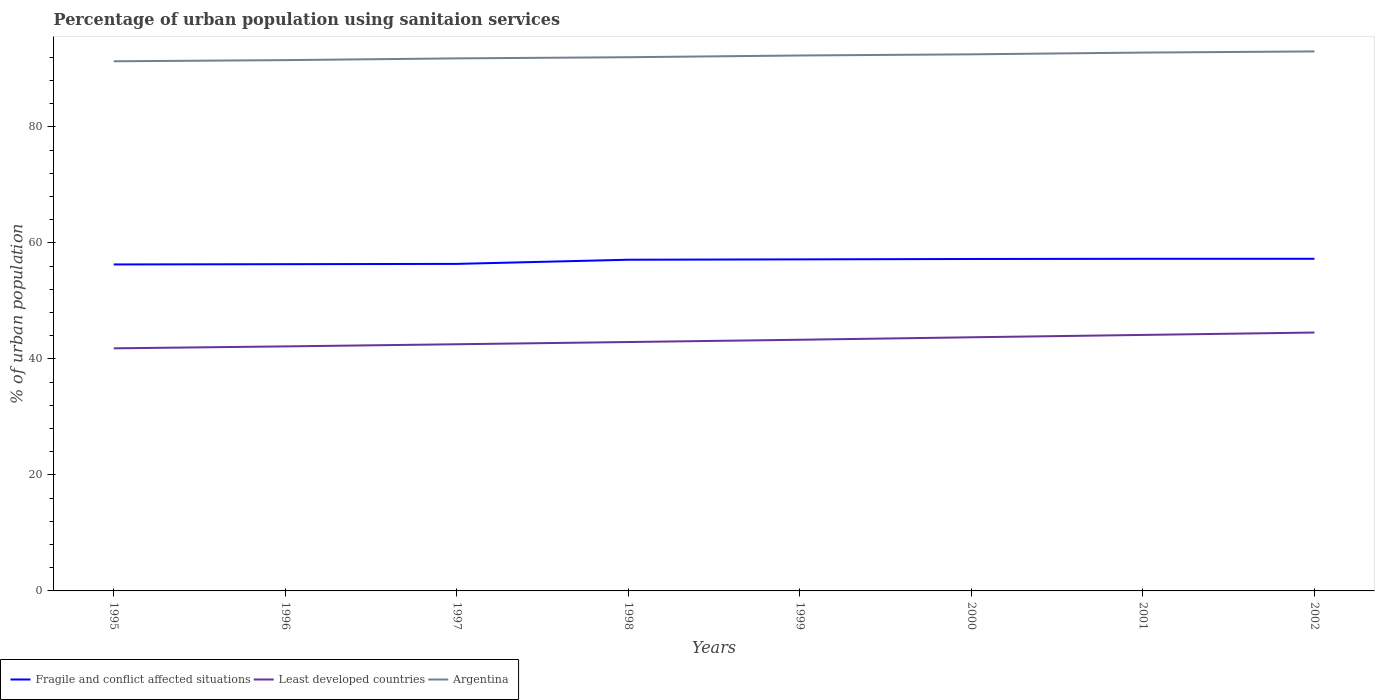Does the line corresponding to Fragile and conflict affected situations intersect with the line corresponding to Least developed countries?
Ensure brevity in your answer.  No. Is the number of lines equal to the number of legend labels?
Give a very brief answer. Yes. Across all years, what is the maximum percentage of urban population using sanitaion services in Fragile and conflict affected situations?
Provide a succinct answer. 56.28. In which year was the percentage of urban population using sanitaion services in Least developed countries maximum?
Provide a short and direct response. 1995. What is the total percentage of urban population using sanitaion services in Fragile and conflict affected situations in the graph?
Provide a short and direct response. -0.13. What is the difference between the highest and the second highest percentage of urban population using sanitaion services in Argentina?
Provide a succinct answer. 1.7. What is the difference between the highest and the lowest percentage of urban population using sanitaion services in Least developed countries?
Your response must be concise. 4. Is the percentage of urban population using sanitaion services in Least developed countries strictly greater than the percentage of urban population using sanitaion services in Argentina over the years?
Provide a short and direct response. Yes. Does the graph contain any zero values?
Your response must be concise. No. Does the graph contain grids?
Make the answer very short. No. Where does the legend appear in the graph?
Offer a very short reply. Bottom left. How many legend labels are there?
Keep it short and to the point. 3. How are the legend labels stacked?
Offer a very short reply. Horizontal. What is the title of the graph?
Ensure brevity in your answer.  Percentage of urban population using sanitaion services. What is the label or title of the X-axis?
Provide a succinct answer. Years. What is the label or title of the Y-axis?
Offer a very short reply. % of urban population. What is the % of urban population of Fragile and conflict affected situations in 1995?
Offer a very short reply. 56.28. What is the % of urban population in Least developed countries in 1995?
Keep it short and to the point. 41.82. What is the % of urban population of Argentina in 1995?
Your response must be concise. 91.3. What is the % of urban population in Fragile and conflict affected situations in 1996?
Make the answer very short. 56.32. What is the % of urban population of Least developed countries in 1996?
Make the answer very short. 42.15. What is the % of urban population in Argentina in 1996?
Make the answer very short. 91.5. What is the % of urban population in Fragile and conflict affected situations in 1997?
Provide a short and direct response. 56.37. What is the % of urban population in Least developed countries in 1997?
Give a very brief answer. 42.52. What is the % of urban population in Argentina in 1997?
Give a very brief answer. 91.8. What is the % of urban population in Fragile and conflict affected situations in 1998?
Provide a short and direct response. 57.09. What is the % of urban population of Least developed countries in 1998?
Offer a very short reply. 42.9. What is the % of urban population of Argentina in 1998?
Your answer should be very brief. 92. What is the % of urban population in Fragile and conflict affected situations in 1999?
Keep it short and to the point. 57.15. What is the % of urban population in Least developed countries in 1999?
Provide a short and direct response. 43.3. What is the % of urban population in Argentina in 1999?
Give a very brief answer. 92.3. What is the % of urban population in Fragile and conflict affected situations in 2000?
Offer a very short reply. 57.22. What is the % of urban population of Least developed countries in 2000?
Offer a very short reply. 43.72. What is the % of urban population in Argentina in 2000?
Offer a very short reply. 92.5. What is the % of urban population of Fragile and conflict affected situations in 2001?
Keep it short and to the point. 57.25. What is the % of urban population of Least developed countries in 2001?
Make the answer very short. 44.13. What is the % of urban population of Argentina in 2001?
Provide a succinct answer. 92.8. What is the % of urban population in Fragile and conflict affected situations in 2002?
Give a very brief answer. 57.25. What is the % of urban population of Least developed countries in 2002?
Provide a short and direct response. 44.54. What is the % of urban population of Argentina in 2002?
Provide a short and direct response. 93. Across all years, what is the maximum % of urban population in Fragile and conflict affected situations?
Your answer should be very brief. 57.25. Across all years, what is the maximum % of urban population in Least developed countries?
Offer a very short reply. 44.54. Across all years, what is the maximum % of urban population in Argentina?
Ensure brevity in your answer.  93. Across all years, what is the minimum % of urban population of Fragile and conflict affected situations?
Keep it short and to the point. 56.28. Across all years, what is the minimum % of urban population in Least developed countries?
Provide a short and direct response. 41.82. Across all years, what is the minimum % of urban population in Argentina?
Keep it short and to the point. 91.3. What is the total % of urban population in Fragile and conflict affected situations in the graph?
Provide a succinct answer. 454.94. What is the total % of urban population in Least developed countries in the graph?
Provide a succinct answer. 345.09. What is the total % of urban population in Argentina in the graph?
Your answer should be very brief. 737.2. What is the difference between the % of urban population in Fragile and conflict affected situations in 1995 and that in 1996?
Your answer should be compact. -0.05. What is the difference between the % of urban population in Least developed countries in 1995 and that in 1996?
Offer a terse response. -0.33. What is the difference between the % of urban population of Fragile and conflict affected situations in 1995 and that in 1997?
Your response must be concise. -0.1. What is the difference between the % of urban population of Least developed countries in 1995 and that in 1997?
Offer a terse response. -0.7. What is the difference between the % of urban population in Argentina in 1995 and that in 1997?
Provide a succinct answer. -0.5. What is the difference between the % of urban population of Fragile and conflict affected situations in 1995 and that in 1998?
Offer a terse response. -0.82. What is the difference between the % of urban population in Least developed countries in 1995 and that in 1998?
Offer a very short reply. -1.08. What is the difference between the % of urban population in Fragile and conflict affected situations in 1995 and that in 1999?
Make the answer very short. -0.88. What is the difference between the % of urban population of Least developed countries in 1995 and that in 1999?
Your answer should be compact. -1.48. What is the difference between the % of urban population of Argentina in 1995 and that in 1999?
Your answer should be very brief. -1. What is the difference between the % of urban population in Fragile and conflict affected situations in 1995 and that in 2000?
Give a very brief answer. -0.94. What is the difference between the % of urban population of Least developed countries in 1995 and that in 2000?
Offer a terse response. -1.9. What is the difference between the % of urban population of Fragile and conflict affected situations in 1995 and that in 2001?
Ensure brevity in your answer.  -0.97. What is the difference between the % of urban population in Least developed countries in 1995 and that in 2001?
Your answer should be very brief. -2.31. What is the difference between the % of urban population of Fragile and conflict affected situations in 1995 and that in 2002?
Your response must be concise. -0.98. What is the difference between the % of urban population of Least developed countries in 1995 and that in 2002?
Provide a succinct answer. -2.72. What is the difference between the % of urban population in Argentina in 1995 and that in 2002?
Ensure brevity in your answer.  -1.7. What is the difference between the % of urban population of Fragile and conflict affected situations in 1996 and that in 1997?
Your answer should be compact. -0.05. What is the difference between the % of urban population in Least developed countries in 1996 and that in 1997?
Your answer should be very brief. -0.37. What is the difference between the % of urban population of Fragile and conflict affected situations in 1996 and that in 1998?
Your response must be concise. -0.77. What is the difference between the % of urban population in Least developed countries in 1996 and that in 1998?
Your response must be concise. -0.75. What is the difference between the % of urban population in Argentina in 1996 and that in 1998?
Keep it short and to the point. -0.5. What is the difference between the % of urban population of Fragile and conflict affected situations in 1996 and that in 1999?
Your response must be concise. -0.83. What is the difference between the % of urban population in Least developed countries in 1996 and that in 1999?
Keep it short and to the point. -1.14. What is the difference between the % of urban population in Argentina in 1996 and that in 1999?
Your response must be concise. -0.8. What is the difference between the % of urban population of Fragile and conflict affected situations in 1996 and that in 2000?
Provide a short and direct response. -0.9. What is the difference between the % of urban population in Least developed countries in 1996 and that in 2000?
Ensure brevity in your answer.  -1.57. What is the difference between the % of urban population in Argentina in 1996 and that in 2000?
Offer a terse response. -1. What is the difference between the % of urban population in Fragile and conflict affected situations in 1996 and that in 2001?
Provide a succinct answer. -0.93. What is the difference between the % of urban population in Least developed countries in 1996 and that in 2001?
Make the answer very short. -1.98. What is the difference between the % of urban population of Argentina in 1996 and that in 2001?
Provide a succinct answer. -1.3. What is the difference between the % of urban population of Fragile and conflict affected situations in 1996 and that in 2002?
Your answer should be very brief. -0.93. What is the difference between the % of urban population of Least developed countries in 1996 and that in 2002?
Your answer should be compact. -2.39. What is the difference between the % of urban population in Fragile and conflict affected situations in 1997 and that in 1998?
Ensure brevity in your answer.  -0.72. What is the difference between the % of urban population of Least developed countries in 1997 and that in 1998?
Give a very brief answer. -0.38. What is the difference between the % of urban population of Argentina in 1997 and that in 1998?
Keep it short and to the point. -0.2. What is the difference between the % of urban population in Fragile and conflict affected situations in 1997 and that in 1999?
Your response must be concise. -0.78. What is the difference between the % of urban population of Least developed countries in 1997 and that in 1999?
Provide a succinct answer. -0.78. What is the difference between the % of urban population in Argentina in 1997 and that in 1999?
Offer a very short reply. -0.5. What is the difference between the % of urban population of Fragile and conflict affected situations in 1997 and that in 2000?
Give a very brief answer. -0.85. What is the difference between the % of urban population of Least developed countries in 1997 and that in 2000?
Offer a terse response. -1.2. What is the difference between the % of urban population of Fragile and conflict affected situations in 1997 and that in 2001?
Ensure brevity in your answer.  -0.88. What is the difference between the % of urban population of Least developed countries in 1997 and that in 2001?
Your answer should be very brief. -1.61. What is the difference between the % of urban population of Fragile and conflict affected situations in 1997 and that in 2002?
Your answer should be very brief. -0.88. What is the difference between the % of urban population in Least developed countries in 1997 and that in 2002?
Give a very brief answer. -2.02. What is the difference between the % of urban population in Argentina in 1997 and that in 2002?
Offer a very short reply. -1.2. What is the difference between the % of urban population of Fragile and conflict affected situations in 1998 and that in 1999?
Provide a short and direct response. -0.06. What is the difference between the % of urban population in Least developed countries in 1998 and that in 1999?
Your answer should be compact. -0.39. What is the difference between the % of urban population of Argentina in 1998 and that in 1999?
Make the answer very short. -0.3. What is the difference between the % of urban population in Fragile and conflict affected situations in 1998 and that in 2000?
Your response must be concise. -0.13. What is the difference between the % of urban population in Least developed countries in 1998 and that in 2000?
Provide a succinct answer. -0.82. What is the difference between the % of urban population of Argentina in 1998 and that in 2000?
Keep it short and to the point. -0.5. What is the difference between the % of urban population in Fragile and conflict affected situations in 1998 and that in 2001?
Make the answer very short. -0.16. What is the difference between the % of urban population of Least developed countries in 1998 and that in 2001?
Provide a short and direct response. -1.23. What is the difference between the % of urban population in Fragile and conflict affected situations in 1998 and that in 2002?
Your answer should be compact. -0.16. What is the difference between the % of urban population in Least developed countries in 1998 and that in 2002?
Your answer should be compact. -1.64. What is the difference between the % of urban population of Argentina in 1998 and that in 2002?
Offer a very short reply. -1. What is the difference between the % of urban population of Fragile and conflict affected situations in 1999 and that in 2000?
Give a very brief answer. -0.07. What is the difference between the % of urban population of Least developed countries in 1999 and that in 2000?
Offer a very short reply. -0.42. What is the difference between the % of urban population in Fragile and conflict affected situations in 1999 and that in 2001?
Your answer should be very brief. -0.1. What is the difference between the % of urban population in Least developed countries in 1999 and that in 2001?
Give a very brief answer. -0.83. What is the difference between the % of urban population of Fragile and conflict affected situations in 1999 and that in 2002?
Provide a succinct answer. -0.1. What is the difference between the % of urban population in Least developed countries in 1999 and that in 2002?
Offer a terse response. -1.24. What is the difference between the % of urban population of Argentina in 1999 and that in 2002?
Offer a terse response. -0.7. What is the difference between the % of urban population in Fragile and conflict affected situations in 2000 and that in 2001?
Make the answer very short. -0.03. What is the difference between the % of urban population in Least developed countries in 2000 and that in 2001?
Offer a very short reply. -0.41. What is the difference between the % of urban population of Argentina in 2000 and that in 2001?
Your answer should be very brief. -0.3. What is the difference between the % of urban population of Fragile and conflict affected situations in 2000 and that in 2002?
Offer a terse response. -0.03. What is the difference between the % of urban population of Least developed countries in 2000 and that in 2002?
Give a very brief answer. -0.82. What is the difference between the % of urban population in Argentina in 2000 and that in 2002?
Your response must be concise. -0.5. What is the difference between the % of urban population of Fragile and conflict affected situations in 2001 and that in 2002?
Your answer should be very brief. -0. What is the difference between the % of urban population in Least developed countries in 2001 and that in 2002?
Your response must be concise. -0.41. What is the difference between the % of urban population of Fragile and conflict affected situations in 1995 and the % of urban population of Least developed countries in 1996?
Your response must be concise. 14.12. What is the difference between the % of urban population of Fragile and conflict affected situations in 1995 and the % of urban population of Argentina in 1996?
Offer a terse response. -35.22. What is the difference between the % of urban population of Least developed countries in 1995 and the % of urban population of Argentina in 1996?
Make the answer very short. -49.68. What is the difference between the % of urban population in Fragile and conflict affected situations in 1995 and the % of urban population in Least developed countries in 1997?
Offer a terse response. 13.75. What is the difference between the % of urban population in Fragile and conflict affected situations in 1995 and the % of urban population in Argentina in 1997?
Your answer should be very brief. -35.52. What is the difference between the % of urban population in Least developed countries in 1995 and the % of urban population in Argentina in 1997?
Provide a short and direct response. -49.98. What is the difference between the % of urban population of Fragile and conflict affected situations in 1995 and the % of urban population of Least developed countries in 1998?
Your response must be concise. 13.37. What is the difference between the % of urban population of Fragile and conflict affected situations in 1995 and the % of urban population of Argentina in 1998?
Ensure brevity in your answer.  -35.72. What is the difference between the % of urban population in Least developed countries in 1995 and the % of urban population in Argentina in 1998?
Your response must be concise. -50.18. What is the difference between the % of urban population in Fragile and conflict affected situations in 1995 and the % of urban population in Least developed countries in 1999?
Your response must be concise. 12.98. What is the difference between the % of urban population in Fragile and conflict affected situations in 1995 and the % of urban population in Argentina in 1999?
Provide a succinct answer. -36.02. What is the difference between the % of urban population of Least developed countries in 1995 and the % of urban population of Argentina in 1999?
Provide a short and direct response. -50.48. What is the difference between the % of urban population in Fragile and conflict affected situations in 1995 and the % of urban population in Least developed countries in 2000?
Your answer should be compact. 12.55. What is the difference between the % of urban population of Fragile and conflict affected situations in 1995 and the % of urban population of Argentina in 2000?
Your response must be concise. -36.22. What is the difference between the % of urban population of Least developed countries in 1995 and the % of urban population of Argentina in 2000?
Ensure brevity in your answer.  -50.68. What is the difference between the % of urban population in Fragile and conflict affected situations in 1995 and the % of urban population in Least developed countries in 2001?
Your answer should be compact. 12.15. What is the difference between the % of urban population in Fragile and conflict affected situations in 1995 and the % of urban population in Argentina in 2001?
Your answer should be compact. -36.52. What is the difference between the % of urban population in Least developed countries in 1995 and the % of urban population in Argentina in 2001?
Ensure brevity in your answer.  -50.98. What is the difference between the % of urban population of Fragile and conflict affected situations in 1995 and the % of urban population of Least developed countries in 2002?
Keep it short and to the point. 11.73. What is the difference between the % of urban population of Fragile and conflict affected situations in 1995 and the % of urban population of Argentina in 2002?
Offer a terse response. -36.72. What is the difference between the % of urban population in Least developed countries in 1995 and the % of urban population in Argentina in 2002?
Your response must be concise. -51.18. What is the difference between the % of urban population in Fragile and conflict affected situations in 1996 and the % of urban population in Least developed countries in 1997?
Ensure brevity in your answer.  13.8. What is the difference between the % of urban population of Fragile and conflict affected situations in 1996 and the % of urban population of Argentina in 1997?
Keep it short and to the point. -35.48. What is the difference between the % of urban population in Least developed countries in 1996 and the % of urban population in Argentina in 1997?
Provide a succinct answer. -49.65. What is the difference between the % of urban population in Fragile and conflict affected situations in 1996 and the % of urban population in Least developed countries in 1998?
Your answer should be compact. 13.42. What is the difference between the % of urban population in Fragile and conflict affected situations in 1996 and the % of urban population in Argentina in 1998?
Your answer should be very brief. -35.68. What is the difference between the % of urban population of Least developed countries in 1996 and the % of urban population of Argentina in 1998?
Your answer should be very brief. -49.85. What is the difference between the % of urban population of Fragile and conflict affected situations in 1996 and the % of urban population of Least developed countries in 1999?
Provide a short and direct response. 13.03. What is the difference between the % of urban population in Fragile and conflict affected situations in 1996 and the % of urban population in Argentina in 1999?
Give a very brief answer. -35.98. What is the difference between the % of urban population in Least developed countries in 1996 and the % of urban population in Argentina in 1999?
Keep it short and to the point. -50.15. What is the difference between the % of urban population of Fragile and conflict affected situations in 1996 and the % of urban population of Least developed countries in 2000?
Provide a short and direct response. 12.6. What is the difference between the % of urban population of Fragile and conflict affected situations in 1996 and the % of urban population of Argentina in 2000?
Give a very brief answer. -36.18. What is the difference between the % of urban population in Least developed countries in 1996 and the % of urban population in Argentina in 2000?
Ensure brevity in your answer.  -50.35. What is the difference between the % of urban population in Fragile and conflict affected situations in 1996 and the % of urban population in Least developed countries in 2001?
Your answer should be compact. 12.19. What is the difference between the % of urban population in Fragile and conflict affected situations in 1996 and the % of urban population in Argentina in 2001?
Your response must be concise. -36.48. What is the difference between the % of urban population in Least developed countries in 1996 and the % of urban population in Argentina in 2001?
Ensure brevity in your answer.  -50.65. What is the difference between the % of urban population of Fragile and conflict affected situations in 1996 and the % of urban population of Least developed countries in 2002?
Make the answer very short. 11.78. What is the difference between the % of urban population in Fragile and conflict affected situations in 1996 and the % of urban population in Argentina in 2002?
Offer a terse response. -36.68. What is the difference between the % of urban population of Least developed countries in 1996 and the % of urban population of Argentina in 2002?
Give a very brief answer. -50.85. What is the difference between the % of urban population in Fragile and conflict affected situations in 1997 and the % of urban population in Least developed countries in 1998?
Provide a succinct answer. 13.47. What is the difference between the % of urban population in Fragile and conflict affected situations in 1997 and the % of urban population in Argentina in 1998?
Provide a succinct answer. -35.63. What is the difference between the % of urban population in Least developed countries in 1997 and the % of urban population in Argentina in 1998?
Make the answer very short. -49.48. What is the difference between the % of urban population of Fragile and conflict affected situations in 1997 and the % of urban population of Least developed countries in 1999?
Provide a short and direct response. 13.08. What is the difference between the % of urban population in Fragile and conflict affected situations in 1997 and the % of urban population in Argentina in 1999?
Ensure brevity in your answer.  -35.93. What is the difference between the % of urban population of Least developed countries in 1997 and the % of urban population of Argentina in 1999?
Make the answer very short. -49.78. What is the difference between the % of urban population in Fragile and conflict affected situations in 1997 and the % of urban population in Least developed countries in 2000?
Provide a short and direct response. 12.65. What is the difference between the % of urban population of Fragile and conflict affected situations in 1997 and the % of urban population of Argentina in 2000?
Make the answer very short. -36.13. What is the difference between the % of urban population in Least developed countries in 1997 and the % of urban population in Argentina in 2000?
Your answer should be compact. -49.98. What is the difference between the % of urban population in Fragile and conflict affected situations in 1997 and the % of urban population in Least developed countries in 2001?
Make the answer very short. 12.24. What is the difference between the % of urban population in Fragile and conflict affected situations in 1997 and the % of urban population in Argentina in 2001?
Offer a very short reply. -36.43. What is the difference between the % of urban population in Least developed countries in 1997 and the % of urban population in Argentina in 2001?
Provide a succinct answer. -50.28. What is the difference between the % of urban population of Fragile and conflict affected situations in 1997 and the % of urban population of Least developed countries in 2002?
Offer a very short reply. 11.83. What is the difference between the % of urban population in Fragile and conflict affected situations in 1997 and the % of urban population in Argentina in 2002?
Offer a terse response. -36.63. What is the difference between the % of urban population of Least developed countries in 1997 and the % of urban population of Argentina in 2002?
Give a very brief answer. -50.48. What is the difference between the % of urban population in Fragile and conflict affected situations in 1998 and the % of urban population in Least developed countries in 1999?
Keep it short and to the point. 13.79. What is the difference between the % of urban population in Fragile and conflict affected situations in 1998 and the % of urban population in Argentina in 1999?
Make the answer very short. -35.21. What is the difference between the % of urban population in Least developed countries in 1998 and the % of urban population in Argentina in 1999?
Your answer should be very brief. -49.4. What is the difference between the % of urban population in Fragile and conflict affected situations in 1998 and the % of urban population in Least developed countries in 2000?
Your answer should be compact. 13.37. What is the difference between the % of urban population of Fragile and conflict affected situations in 1998 and the % of urban population of Argentina in 2000?
Provide a succinct answer. -35.41. What is the difference between the % of urban population in Least developed countries in 1998 and the % of urban population in Argentina in 2000?
Provide a succinct answer. -49.6. What is the difference between the % of urban population of Fragile and conflict affected situations in 1998 and the % of urban population of Least developed countries in 2001?
Offer a very short reply. 12.96. What is the difference between the % of urban population in Fragile and conflict affected situations in 1998 and the % of urban population in Argentina in 2001?
Your response must be concise. -35.71. What is the difference between the % of urban population of Least developed countries in 1998 and the % of urban population of Argentina in 2001?
Offer a very short reply. -49.9. What is the difference between the % of urban population of Fragile and conflict affected situations in 1998 and the % of urban population of Least developed countries in 2002?
Your response must be concise. 12.55. What is the difference between the % of urban population of Fragile and conflict affected situations in 1998 and the % of urban population of Argentina in 2002?
Offer a very short reply. -35.91. What is the difference between the % of urban population of Least developed countries in 1998 and the % of urban population of Argentina in 2002?
Your answer should be compact. -50.1. What is the difference between the % of urban population of Fragile and conflict affected situations in 1999 and the % of urban population of Least developed countries in 2000?
Give a very brief answer. 13.43. What is the difference between the % of urban population in Fragile and conflict affected situations in 1999 and the % of urban population in Argentina in 2000?
Give a very brief answer. -35.35. What is the difference between the % of urban population of Least developed countries in 1999 and the % of urban population of Argentina in 2000?
Your answer should be compact. -49.2. What is the difference between the % of urban population in Fragile and conflict affected situations in 1999 and the % of urban population in Least developed countries in 2001?
Offer a terse response. 13.02. What is the difference between the % of urban population in Fragile and conflict affected situations in 1999 and the % of urban population in Argentina in 2001?
Keep it short and to the point. -35.65. What is the difference between the % of urban population in Least developed countries in 1999 and the % of urban population in Argentina in 2001?
Keep it short and to the point. -49.5. What is the difference between the % of urban population in Fragile and conflict affected situations in 1999 and the % of urban population in Least developed countries in 2002?
Keep it short and to the point. 12.61. What is the difference between the % of urban population of Fragile and conflict affected situations in 1999 and the % of urban population of Argentina in 2002?
Offer a terse response. -35.85. What is the difference between the % of urban population in Least developed countries in 1999 and the % of urban population in Argentina in 2002?
Keep it short and to the point. -49.7. What is the difference between the % of urban population in Fragile and conflict affected situations in 2000 and the % of urban population in Least developed countries in 2001?
Offer a very short reply. 13.09. What is the difference between the % of urban population in Fragile and conflict affected situations in 2000 and the % of urban population in Argentina in 2001?
Keep it short and to the point. -35.58. What is the difference between the % of urban population in Least developed countries in 2000 and the % of urban population in Argentina in 2001?
Offer a terse response. -49.08. What is the difference between the % of urban population of Fragile and conflict affected situations in 2000 and the % of urban population of Least developed countries in 2002?
Provide a succinct answer. 12.68. What is the difference between the % of urban population in Fragile and conflict affected situations in 2000 and the % of urban population in Argentina in 2002?
Make the answer very short. -35.78. What is the difference between the % of urban population in Least developed countries in 2000 and the % of urban population in Argentina in 2002?
Provide a succinct answer. -49.28. What is the difference between the % of urban population in Fragile and conflict affected situations in 2001 and the % of urban population in Least developed countries in 2002?
Offer a terse response. 12.71. What is the difference between the % of urban population of Fragile and conflict affected situations in 2001 and the % of urban population of Argentina in 2002?
Your answer should be very brief. -35.75. What is the difference between the % of urban population of Least developed countries in 2001 and the % of urban population of Argentina in 2002?
Offer a terse response. -48.87. What is the average % of urban population of Fragile and conflict affected situations per year?
Make the answer very short. 56.87. What is the average % of urban population in Least developed countries per year?
Keep it short and to the point. 43.14. What is the average % of urban population of Argentina per year?
Keep it short and to the point. 92.15. In the year 1995, what is the difference between the % of urban population in Fragile and conflict affected situations and % of urban population in Least developed countries?
Offer a very short reply. 14.46. In the year 1995, what is the difference between the % of urban population in Fragile and conflict affected situations and % of urban population in Argentina?
Provide a short and direct response. -35.02. In the year 1995, what is the difference between the % of urban population in Least developed countries and % of urban population in Argentina?
Provide a short and direct response. -49.48. In the year 1996, what is the difference between the % of urban population in Fragile and conflict affected situations and % of urban population in Least developed countries?
Give a very brief answer. 14.17. In the year 1996, what is the difference between the % of urban population of Fragile and conflict affected situations and % of urban population of Argentina?
Your answer should be very brief. -35.18. In the year 1996, what is the difference between the % of urban population of Least developed countries and % of urban population of Argentina?
Make the answer very short. -49.35. In the year 1997, what is the difference between the % of urban population of Fragile and conflict affected situations and % of urban population of Least developed countries?
Keep it short and to the point. 13.85. In the year 1997, what is the difference between the % of urban population in Fragile and conflict affected situations and % of urban population in Argentina?
Ensure brevity in your answer.  -35.43. In the year 1997, what is the difference between the % of urban population of Least developed countries and % of urban population of Argentina?
Provide a short and direct response. -49.28. In the year 1998, what is the difference between the % of urban population in Fragile and conflict affected situations and % of urban population in Least developed countries?
Provide a succinct answer. 14.19. In the year 1998, what is the difference between the % of urban population of Fragile and conflict affected situations and % of urban population of Argentina?
Provide a succinct answer. -34.91. In the year 1998, what is the difference between the % of urban population in Least developed countries and % of urban population in Argentina?
Provide a succinct answer. -49.1. In the year 1999, what is the difference between the % of urban population in Fragile and conflict affected situations and % of urban population in Least developed countries?
Offer a terse response. 13.85. In the year 1999, what is the difference between the % of urban population in Fragile and conflict affected situations and % of urban population in Argentina?
Ensure brevity in your answer.  -35.15. In the year 1999, what is the difference between the % of urban population of Least developed countries and % of urban population of Argentina?
Your answer should be compact. -49. In the year 2000, what is the difference between the % of urban population in Fragile and conflict affected situations and % of urban population in Least developed countries?
Provide a short and direct response. 13.5. In the year 2000, what is the difference between the % of urban population of Fragile and conflict affected situations and % of urban population of Argentina?
Your answer should be very brief. -35.28. In the year 2000, what is the difference between the % of urban population of Least developed countries and % of urban population of Argentina?
Provide a short and direct response. -48.78. In the year 2001, what is the difference between the % of urban population of Fragile and conflict affected situations and % of urban population of Least developed countries?
Offer a very short reply. 13.12. In the year 2001, what is the difference between the % of urban population of Fragile and conflict affected situations and % of urban population of Argentina?
Your response must be concise. -35.55. In the year 2001, what is the difference between the % of urban population in Least developed countries and % of urban population in Argentina?
Offer a terse response. -48.67. In the year 2002, what is the difference between the % of urban population of Fragile and conflict affected situations and % of urban population of Least developed countries?
Provide a short and direct response. 12.71. In the year 2002, what is the difference between the % of urban population of Fragile and conflict affected situations and % of urban population of Argentina?
Give a very brief answer. -35.75. In the year 2002, what is the difference between the % of urban population in Least developed countries and % of urban population in Argentina?
Provide a short and direct response. -48.46. What is the ratio of the % of urban population of Least developed countries in 1995 to that in 1996?
Your answer should be very brief. 0.99. What is the ratio of the % of urban population in Fragile and conflict affected situations in 1995 to that in 1997?
Make the answer very short. 1. What is the ratio of the % of urban population of Least developed countries in 1995 to that in 1997?
Give a very brief answer. 0.98. What is the ratio of the % of urban population of Fragile and conflict affected situations in 1995 to that in 1998?
Provide a succinct answer. 0.99. What is the ratio of the % of urban population of Least developed countries in 1995 to that in 1998?
Your answer should be compact. 0.97. What is the ratio of the % of urban population in Argentina in 1995 to that in 1998?
Keep it short and to the point. 0.99. What is the ratio of the % of urban population of Fragile and conflict affected situations in 1995 to that in 1999?
Give a very brief answer. 0.98. What is the ratio of the % of urban population in Least developed countries in 1995 to that in 1999?
Offer a terse response. 0.97. What is the ratio of the % of urban population of Argentina in 1995 to that in 1999?
Your response must be concise. 0.99. What is the ratio of the % of urban population of Fragile and conflict affected situations in 1995 to that in 2000?
Offer a very short reply. 0.98. What is the ratio of the % of urban population in Least developed countries in 1995 to that in 2000?
Give a very brief answer. 0.96. What is the ratio of the % of urban population of Fragile and conflict affected situations in 1995 to that in 2001?
Make the answer very short. 0.98. What is the ratio of the % of urban population in Least developed countries in 1995 to that in 2001?
Provide a succinct answer. 0.95. What is the ratio of the % of urban population of Argentina in 1995 to that in 2001?
Make the answer very short. 0.98. What is the ratio of the % of urban population in Fragile and conflict affected situations in 1995 to that in 2002?
Your answer should be compact. 0.98. What is the ratio of the % of urban population in Least developed countries in 1995 to that in 2002?
Provide a short and direct response. 0.94. What is the ratio of the % of urban population of Argentina in 1995 to that in 2002?
Make the answer very short. 0.98. What is the ratio of the % of urban population of Fragile and conflict affected situations in 1996 to that in 1997?
Offer a very short reply. 1. What is the ratio of the % of urban population in Fragile and conflict affected situations in 1996 to that in 1998?
Provide a short and direct response. 0.99. What is the ratio of the % of urban population in Least developed countries in 1996 to that in 1998?
Your response must be concise. 0.98. What is the ratio of the % of urban population of Argentina in 1996 to that in 1998?
Your answer should be very brief. 0.99. What is the ratio of the % of urban population in Fragile and conflict affected situations in 1996 to that in 1999?
Keep it short and to the point. 0.99. What is the ratio of the % of urban population of Least developed countries in 1996 to that in 1999?
Ensure brevity in your answer.  0.97. What is the ratio of the % of urban population of Argentina in 1996 to that in 1999?
Make the answer very short. 0.99. What is the ratio of the % of urban population in Fragile and conflict affected situations in 1996 to that in 2000?
Offer a terse response. 0.98. What is the ratio of the % of urban population of Least developed countries in 1996 to that in 2000?
Your response must be concise. 0.96. What is the ratio of the % of urban population in Fragile and conflict affected situations in 1996 to that in 2001?
Provide a short and direct response. 0.98. What is the ratio of the % of urban population in Least developed countries in 1996 to that in 2001?
Offer a terse response. 0.96. What is the ratio of the % of urban population in Fragile and conflict affected situations in 1996 to that in 2002?
Give a very brief answer. 0.98. What is the ratio of the % of urban population in Least developed countries in 1996 to that in 2002?
Keep it short and to the point. 0.95. What is the ratio of the % of urban population of Argentina in 1996 to that in 2002?
Keep it short and to the point. 0.98. What is the ratio of the % of urban population of Fragile and conflict affected situations in 1997 to that in 1998?
Provide a succinct answer. 0.99. What is the ratio of the % of urban population in Least developed countries in 1997 to that in 1998?
Ensure brevity in your answer.  0.99. What is the ratio of the % of urban population of Fragile and conflict affected situations in 1997 to that in 1999?
Make the answer very short. 0.99. What is the ratio of the % of urban population of Least developed countries in 1997 to that in 1999?
Make the answer very short. 0.98. What is the ratio of the % of urban population in Fragile and conflict affected situations in 1997 to that in 2000?
Your response must be concise. 0.99. What is the ratio of the % of urban population of Least developed countries in 1997 to that in 2000?
Ensure brevity in your answer.  0.97. What is the ratio of the % of urban population of Fragile and conflict affected situations in 1997 to that in 2001?
Make the answer very short. 0.98. What is the ratio of the % of urban population in Least developed countries in 1997 to that in 2001?
Make the answer very short. 0.96. What is the ratio of the % of urban population of Fragile and conflict affected situations in 1997 to that in 2002?
Provide a short and direct response. 0.98. What is the ratio of the % of urban population in Least developed countries in 1997 to that in 2002?
Provide a short and direct response. 0.95. What is the ratio of the % of urban population in Argentina in 1997 to that in 2002?
Give a very brief answer. 0.99. What is the ratio of the % of urban population in Fragile and conflict affected situations in 1998 to that in 1999?
Provide a succinct answer. 1. What is the ratio of the % of urban population in Least developed countries in 1998 to that in 1999?
Your response must be concise. 0.99. What is the ratio of the % of urban population in Argentina in 1998 to that in 1999?
Provide a short and direct response. 1. What is the ratio of the % of urban population in Least developed countries in 1998 to that in 2000?
Offer a terse response. 0.98. What is the ratio of the % of urban population in Fragile and conflict affected situations in 1998 to that in 2001?
Make the answer very short. 1. What is the ratio of the % of urban population of Least developed countries in 1998 to that in 2001?
Provide a short and direct response. 0.97. What is the ratio of the % of urban population in Argentina in 1998 to that in 2001?
Offer a very short reply. 0.99. What is the ratio of the % of urban population in Fragile and conflict affected situations in 1998 to that in 2002?
Your response must be concise. 1. What is the ratio of the % of urban population in Least developed countries in 1998 to that in 2002?
Offer a very short reply. 0.96. What is the ratio of the % of urban population in Argentina in 1998 to that in 2002?
Make the answer very short. 0.99. What is the ratio of the % of urban population in Fragile and conflict affected situations in 1999 to that in 2000?
Keep it short and to the point. 1. What is the ratio of the % of urban population in Least developed countries in 1999 to that in 2000?
Make the answer very short. 0.99. What is the ratio of the % of urban population in Fragile and conflict affected situations in 1999 to that in 2001?
Give a very brief answer. 1. What is the ratio of the % of urban population in Least developed countries in 1999 to that in 2001?
Give a very brief answer. 0.98. What is the ratio of the % of urban population of Fragile and conflict affected situations in 1999 to that in 2002?
Your answer should be compact. 1. What is the ratio of the % of urban population in Least developed countries in 1999 to that in 2002?
Your answer should be very brief. 0.97. What is the ratio of the % of urban population in Argentina in 1999 to that in 2002?
Offer a very short reply. 0.99. What is the ratio of the % of urban population of Fragile and conflict affected situations in 2000 to that in 2001?
Your answer should be very brief. 1. What is the ratio of the % of urban population of Argentina in 2000 to that in 2001?
Offer a terse response. 1. What is the ratio of the % of urban population in Least developed countries in 2000 to that in 2002?
Provide a short and direct response. 0.98. What is the ratio of the % of urban population in Argentina in 2000 to that in 2002?
Your answer should be compact. 0.99. What is the ratio of the % of urban population in Fragile and conflict affected situations in 2001 to that in 2002?
Your response must be concise. 1. What is the ratio of the % of urban population in Argentina in 2001 to that in 2002?
Keep it short and to the point. 1. What is the difference between the highest and the second highest % of urban population in Fragile and conflict affected situations?
Keep it short and to the point. 0. What is the difference between the highest and the second highest % of urban population in Least developed countries?
Your answer should be very brief. 0.41. What is the difference between the highest and the lowest % of urban population in Fragile and conflict affected situations?
Offer a terse response. 0.98. What is the difference between the highest and the lowest % of urban population of Least developed countries?
Provide a short and direct response. 2.72. What is the difference between the highest and the lowest % of urban population of Argentina?
Your answer should be very brief. 1.7. 